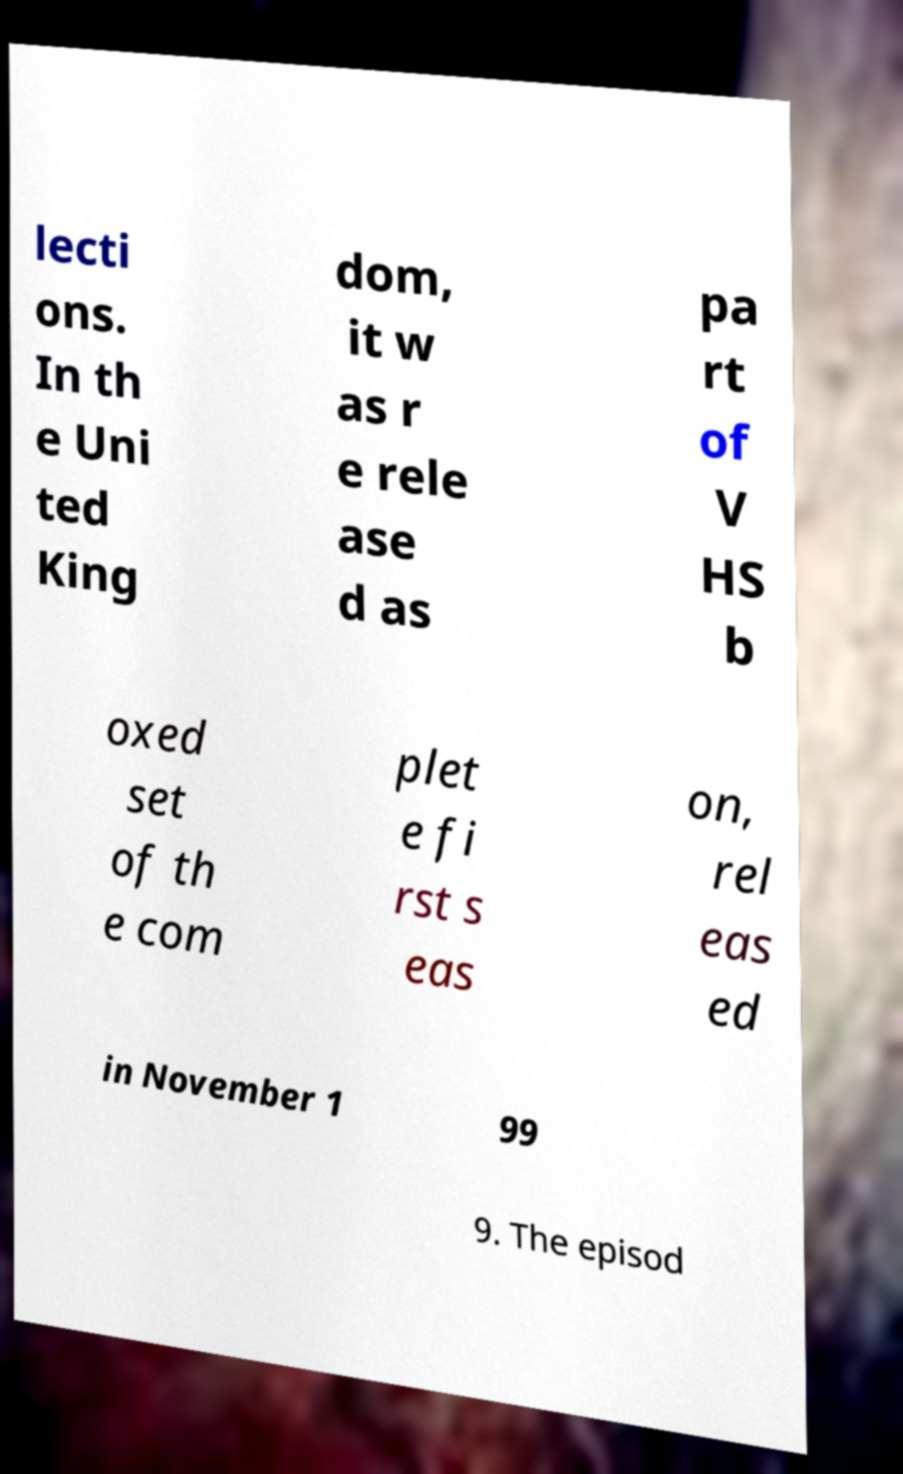There's text embedded in this image that I need extracted. Can you transcribe it verbatim? lecti ons. In th e Uni ted King dom, it w as r e rele ase d as pa rt of V HS b oxed set of th e com plet e fi rst s eas on, rel eas ed in November 1 99 9. The episod 